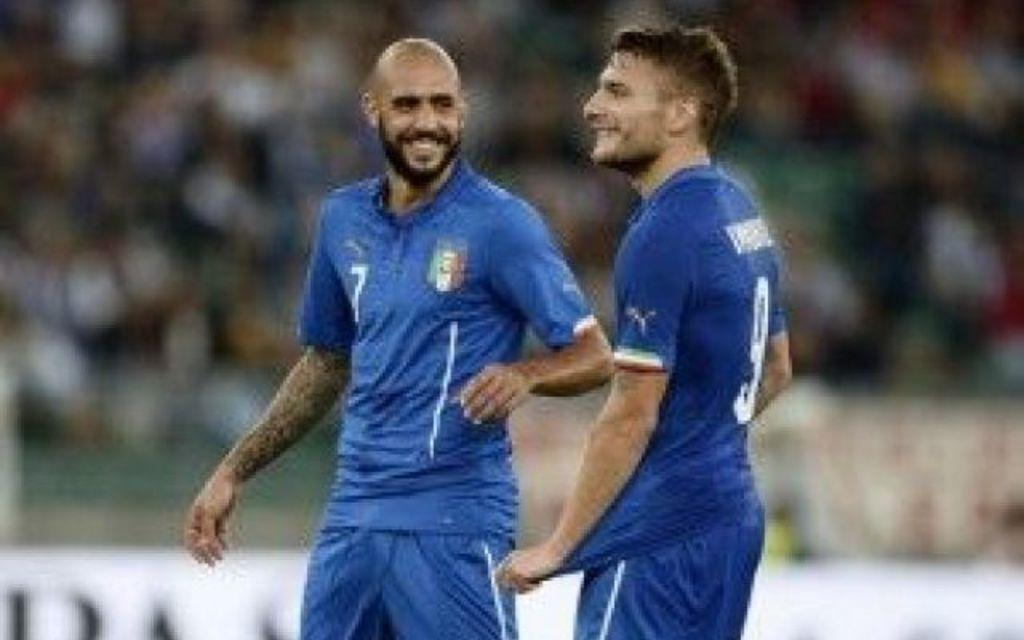How many people are in the image? There are two men in the image. What are the men wearing? Both men are wearing blue color jerseys and shorts. What is the emotional state of the men in the image? The men are laughing. What can be seen in the background of the image? There is a stadium in the background of the image. How is the background of the image depicted? The background is blurred. How many chairs are visible in the image? There are no chairs visible in the image. What type of rhythm can be heard in the image? There is no sound or rhythm present in the image, as it is a still photograph. 